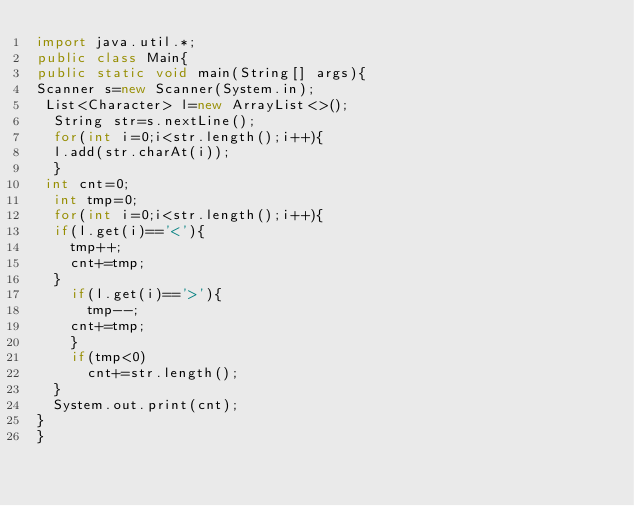Convert code to text. <code><loc_0><loc_0><loc_500><loc_500><_Java_>import java.util.*;
public class Main{
public static void main(String[] args){
Scanner s=new Scanner(System.in);
 List<Character> l=new ArrayList<>();
  String str=s.nextLine();
  for(int i=0;i<str.length();i++){
  l.add(str.charAt(i));
  }
 int cnt=0;
  int tmp=0;
  for(int i=0;i<str.length();i++){
  if(l.get(i)=='<'){
    tmp++;
    cnt+=tmp;
  }
    if(l.get(i)=='>'){
      tmp--;
    cnt+=tmp;
    }
    if(tmp<0)
      cnt+=str.length();
  }
  System.out.print(cnt);
}
}</code> 